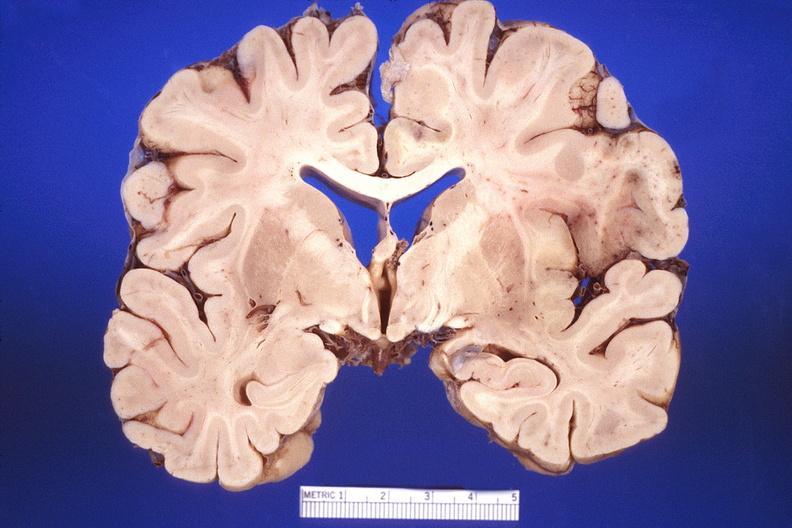s nervous present?
Answer the question using a single word or phrase. Yes 